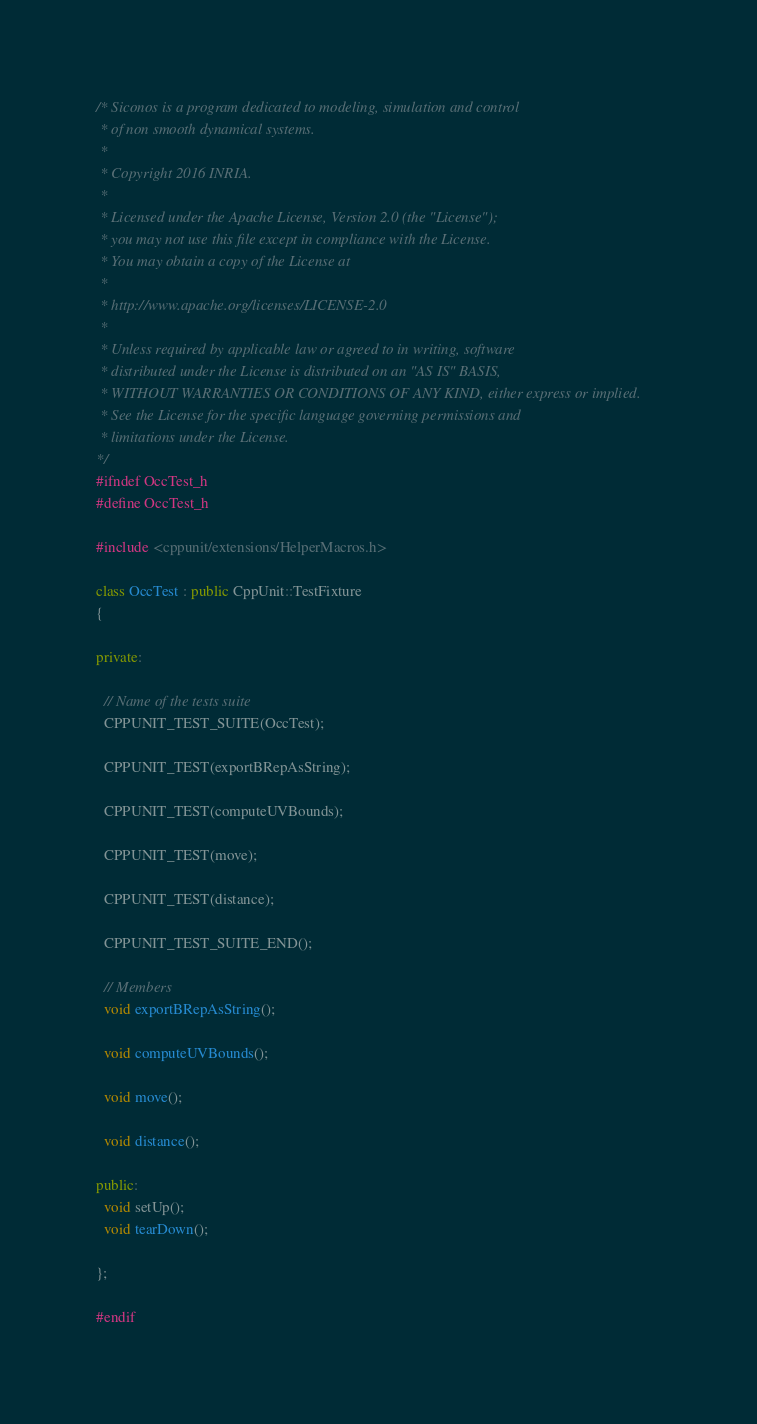<code> <loc_0><loc_0><loc_500><loc_500><_C++_>/* Siconos is a program dedicated to modeling, simulation and control
 * of non smooth dynamical systems.
 *
 * Copyright 2016 INRIA.
 *
 * Licensed under the Apache License, Version 2.0 (the "License");
 * you may not use this file except in compliance with the License.
 * You may obtain a copy of the License at
 *
 * http://www.apache.org/licenses/LICENSE-2.0
 *
 * Unless required by applicable law or agreed to in writing, software
 * distributed under the License is distributed on an "AS IS" BASIS,
 * WITHOUT WARRANTIES OR CONDITIONS OF ANY KIND, either express or implied.
 * See the License for the specific language governing permissions and
 * limitations under the License.
*/
#ifndef OccTest_h
#define OccTest_h

#include <cppunit/extensions/HelperMacros.h>

class OccTest : public CppUnit::TestFixture
{

private:

  // Name of the tests suite
  CPPUNIT_TEST_SUITE(OccTest);

  CPPUNIT_TEST(exportBRepAsString);

  CPPUNIT_TEST(computeUVBounds);

  CPPUNIT_TEST(move);

  CPPUNIT_TEST(distance);

  CPPUNIT_TEST_SUITE_END();

  // Members
  void exportBRepAsString();

  void computeUVBounds();

  void move();

  void distance();

public:
  void setUp();
  void tearDown();

};

#endif
</code> 